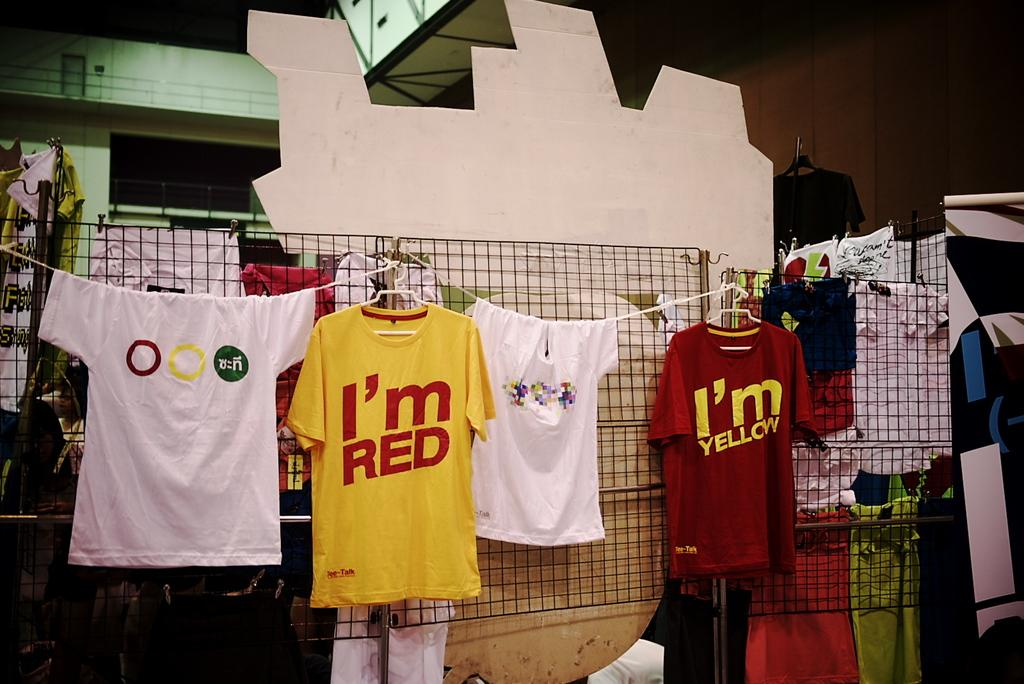<image>
Render a clear and concise summary of the photo. A yellow shirt that has the words "i'm RED" on it 